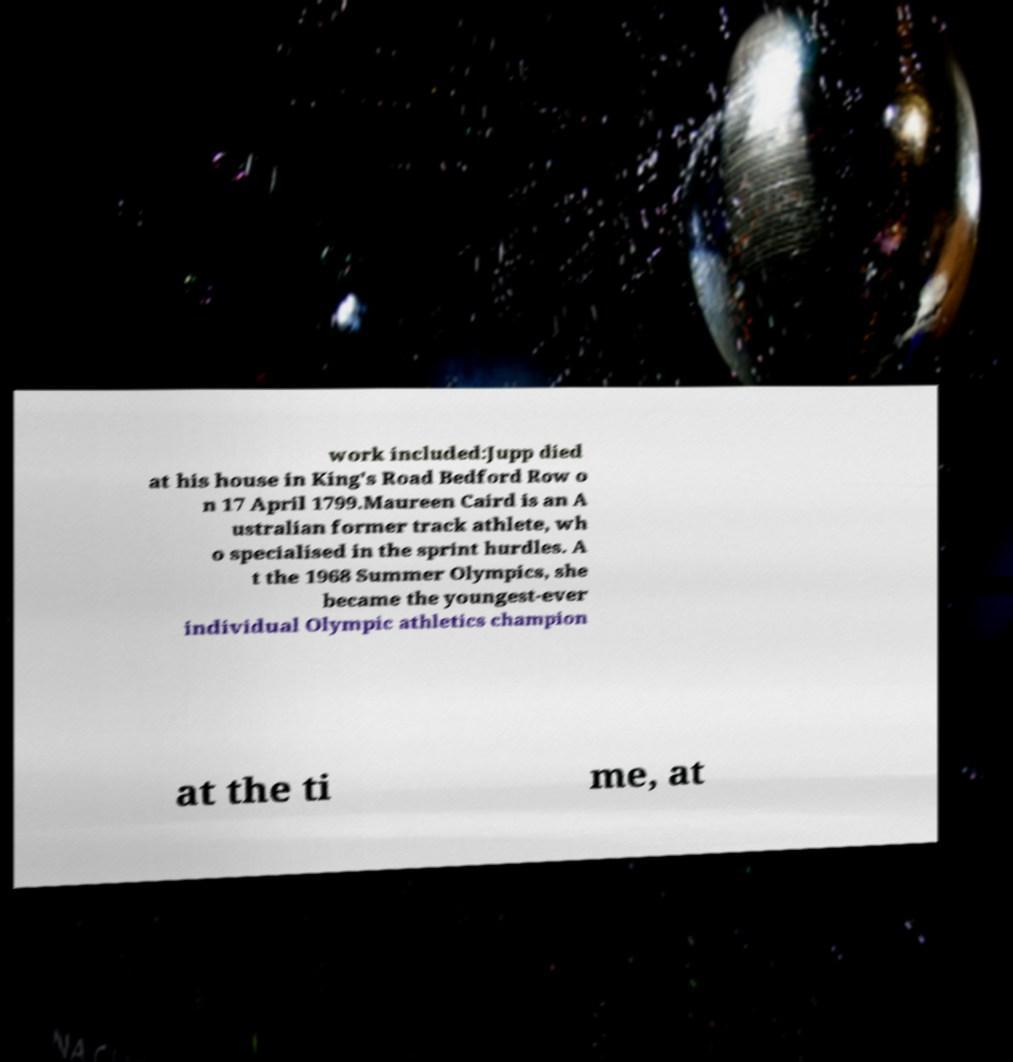Can you accurately transcribe the text from the provided image for me? work included:Jupp died at his house in King's Road Bedford Row o n 17 April 1799.Maureen Caird is an A ustralian former track athlete, wh o specialised in the sprint hurdles. A t the 1968 Summer Olympics, she became the youngest-ever individual Olympic athletics champion at the ti me, at 